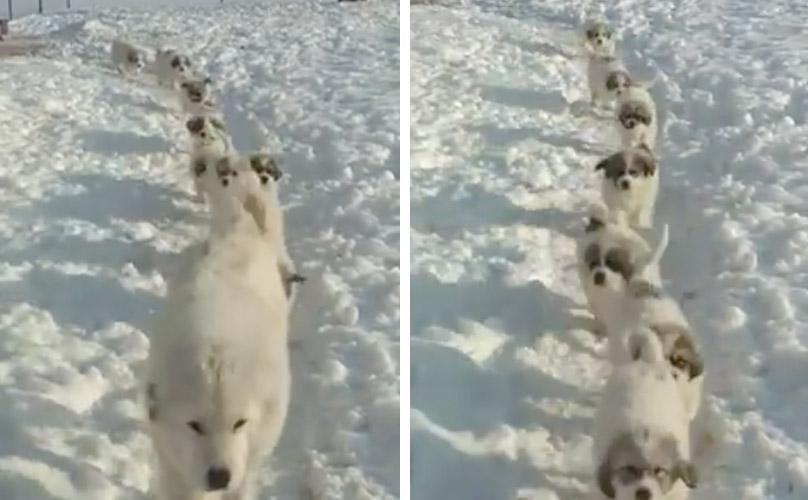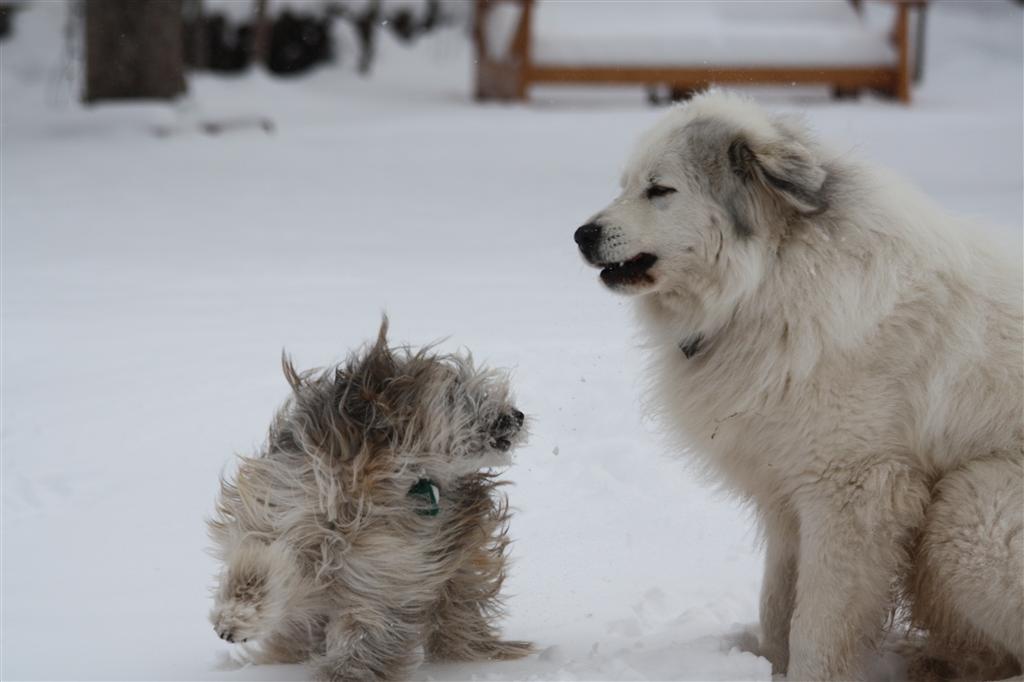The first image is the image on the left, the second image is the image on the right. Considering the images on both sides, is "A dogs lies down in the snow in the image on the left." valid? Answer yes or no. No. The first image is the image on the left, the second image is the image on the right. For the images shown, is this caption "Each image contains a single white dog, and at least one image shows a dog lying on the snow." true? Answer yes or no. No. 